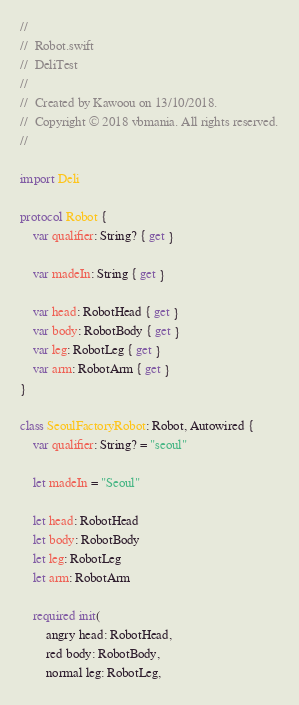Convert code to text. <code><loc_0><loc_0><loc_500><loc_500><_Swift_>//
//  Robot.swift
//  DeliTest
//
//  Created by Kawoou on 13/10/2018.
//  Copyright © 2018 vbmania. All rights reserved.
//

import Deli

protocol Robot {
    var qualifier: String? { get }

    var madeIn: String { get }
    
    var head: RobotHead { get }
    var body: RobotBody { get }
    var leg: RobotLeg { get }
    var arm: RobotArm { get }
}

class SeoulFactoryRobot: Robot, Autowired {
    var qualifier: String? = "seoul"

    let madeIn = "Seoul"

    let head: RobotHead
    let body: RobotBody
    let leg: RobotLeg
    let arm: RobotArm

    required init(
        angry head: RobotHead,
        red body: RobotBody,
        normal leg: RobotLeg,</code> 